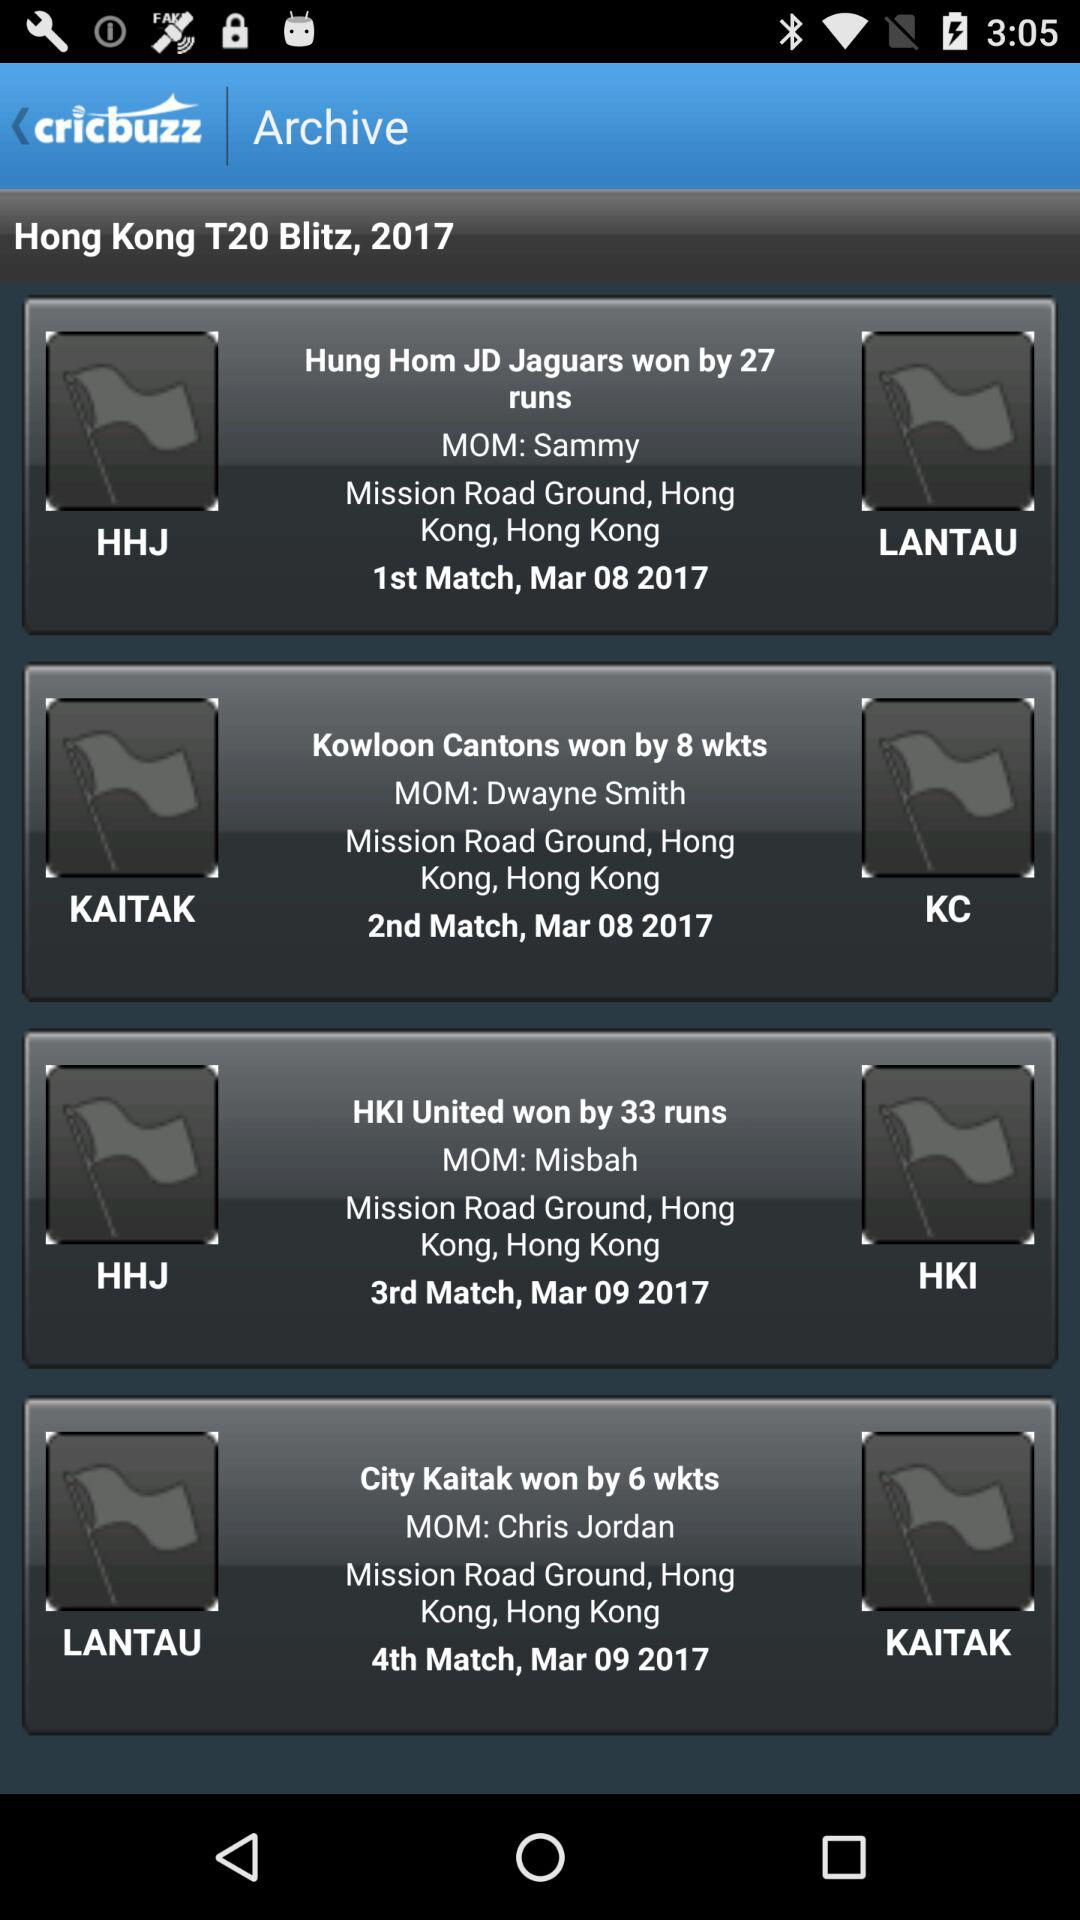What is the mentioned location? The mentioned location is Hong Kong. 